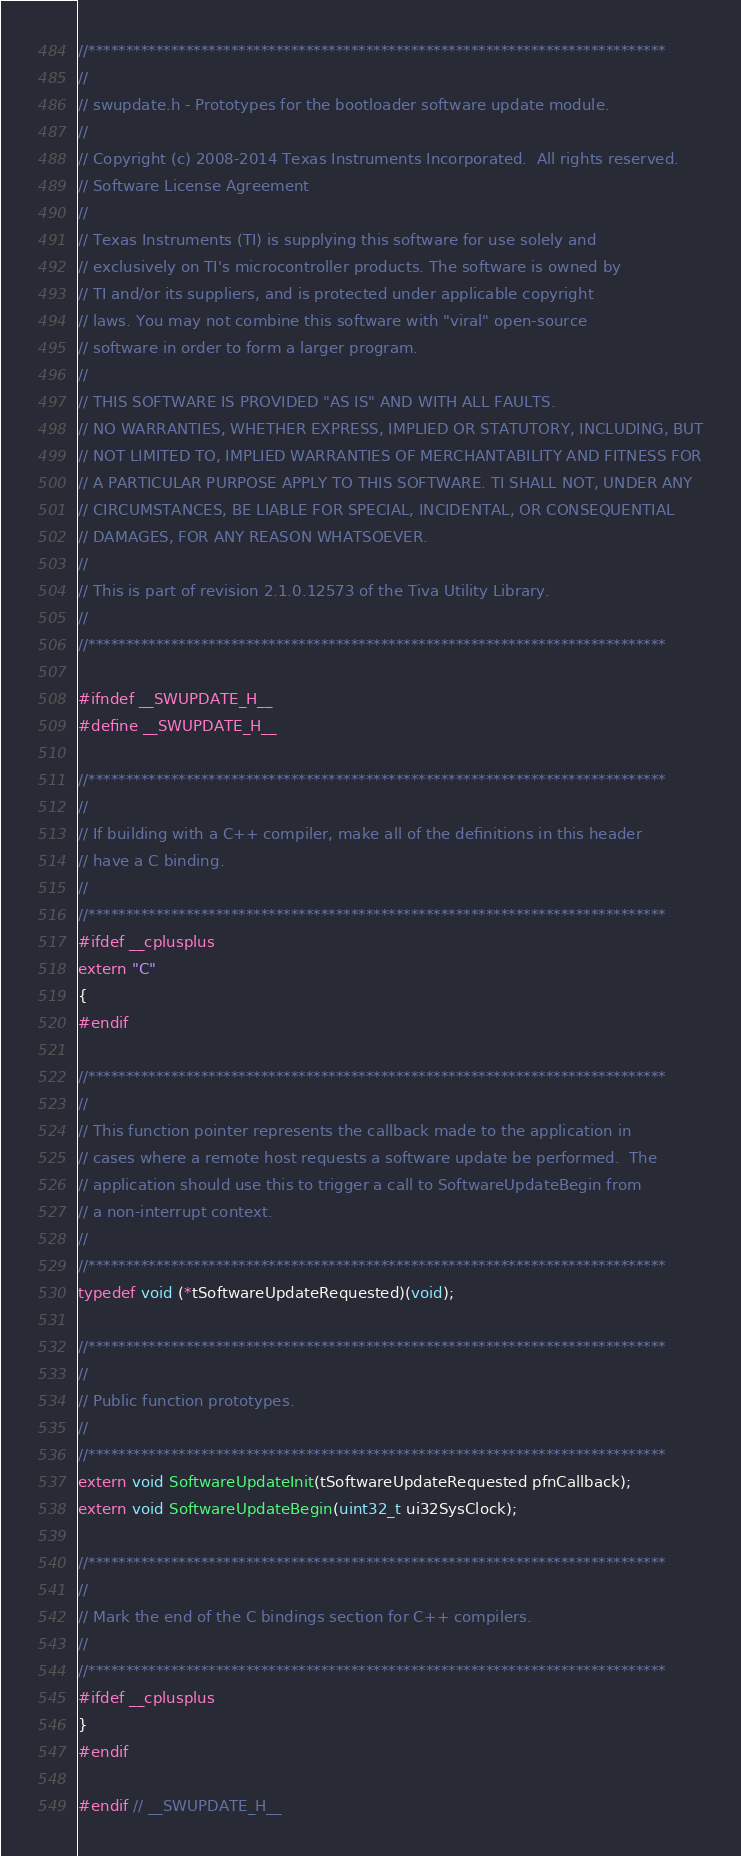Convert code to text. <code><loc_0><loc_0><loc_500><loc_500><_C_>//*****************************************************************************
//
// swupdate.h - Prototypes for the bootloader software update module.
//
// Copyright (c) 2008-2014 Texas Instruments Incorporated.  All rights reserved.
// Software License Agreement
// 
// Texas Instruments (TI) is supplying this software for use solely and
// exclusively on TI's microcontroller products. The software is owned by
// TI and/or its suppliers, and is protected under applicable copyright
// laws. You may not combine this software with "viral" open-source
// software in order to form a larger program.
// 
// THIS SOFTWARE IS PROVIDED "AS IS" AND WITH ALL FAULTS.
// NO WARRANTIES, WHETHER EXPRESS, IMPLIED OR STATUTORY, INCLUDING, BUT
// NOT LIMITED TO, IMPLIED WARRANTIES OF MERCHANTABILITY AND FITNESS FOR
// A PARTICULAR PURPOSE APPLY TO THIS SOFTWARE. TI SHALL NOT, UNDER ANY
// CIRCUMSTANCES, BE LIABLE FOR SPECIAL, INCIDENTAL, OR CONSEQUENTIAL
// DAMAGES, FOR ANY REASON WHATSOEVER.
// 
// This is part of revision 2.1.0.12573 of the Tiva Utility Library.
//
//*****************************************************************************

#ifndef __SWUPDATE_H__
#define __SWUPDATE_H__

//*****************************************************************************
//
// If building with a C++ compiler, make all of the definitions in this header
// have a C binding.
//
//*****************************************************************************
#ifdef __cplusplus
extern "C"
{
#endif

//*****************************************************************************
//
// This function pointer represents the callback made to the application in
// cases where a remote host requests a software update be performed.  The
// application should use this to trigger a call to SoftwareUpdateBegin from
// a non-interrupt context.
//
//*****************************************************************************
typedef void (*tSoftwareUpdateRequested)(void);

//*****************************************************************************
//
// Public function prototypes.
//
//*****************************************************************************
extern void SoftwareUpdateInit(tSoftwareUpdateRequested pfnCallback);
extern void SoftwareUpdateBegin(uint32_t ui32SysClock);

//*****************************************************************************
//
// Mark the end of the C bindings section for C++ compilers.
//
//*****************************************************************************
#ifdef __cplusplus
}
#endif

#endif // __SWUPDATE_H__
</code> 